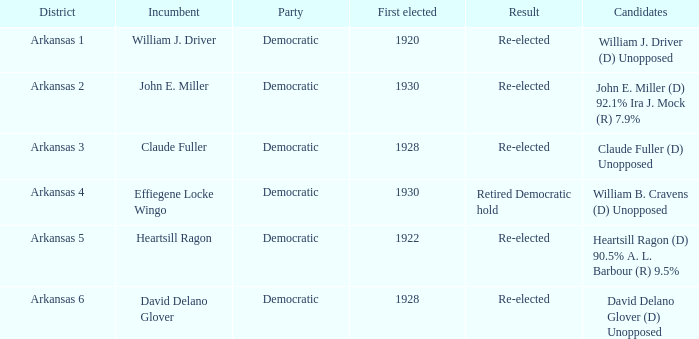In what district was John E. Miller the incumbent?  Arkansas 2. Would you be able to parse every entry in this table? {'header': ['District', 'Incumbent', 'Party', 'First elected', 'Result', 'Candidates'], 'rows': [['Arkansas 1', 'William J. Driver', 'Democratic', '1920', 'Re-elected', 'William J. Driver (D) Unopposed'], ['Arkansas 2', 'John E. Miller', 'Democratic', '1930', 'Re-elected', 'John E. Miller (D) 92.1% Ira J. Mock (R) 7.9%'], ['Arkansas 3', 'Claude Fuller', 'Democratic', '1928', 'Re-elected', 'Claude Fuller (D) Unopposed'], ['Arkansas 4', 'Effiegene Locke Wingo', 'Democratic', '1930', 'Retired Democratic hold', 'William B. Cravens (D) Unopposed'], ['Arkansas 5', 'Heartsill Ragon', 'Democratic', '1922', 'Re-elected', 'Heartsill Ragon (D) 90.5% A. L. Barbour (R) 9.5%'], ['Arkansas 6', 'David Delano Glover', 'Democratic', '1928', 'Re-elected', 'David Delano Glover (D) Unopposed']]} 